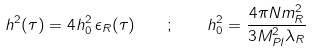Convert formula to latex. <formula><loc_0><loc_0><loc_500><loc_500>h ^ { 2 } ( \tau ) = 4 h ^ { 2 } _ { 0 } \, \epsilon _ { R } ( \tau ) \quad ; \quad h ^ { 2 } _ { 0 } = \frac { 4 \pi N m ^ { 2 } _ { R } } { 3 M ^ { 2 } _ { P l } \lambda _ { R } }</formula> 